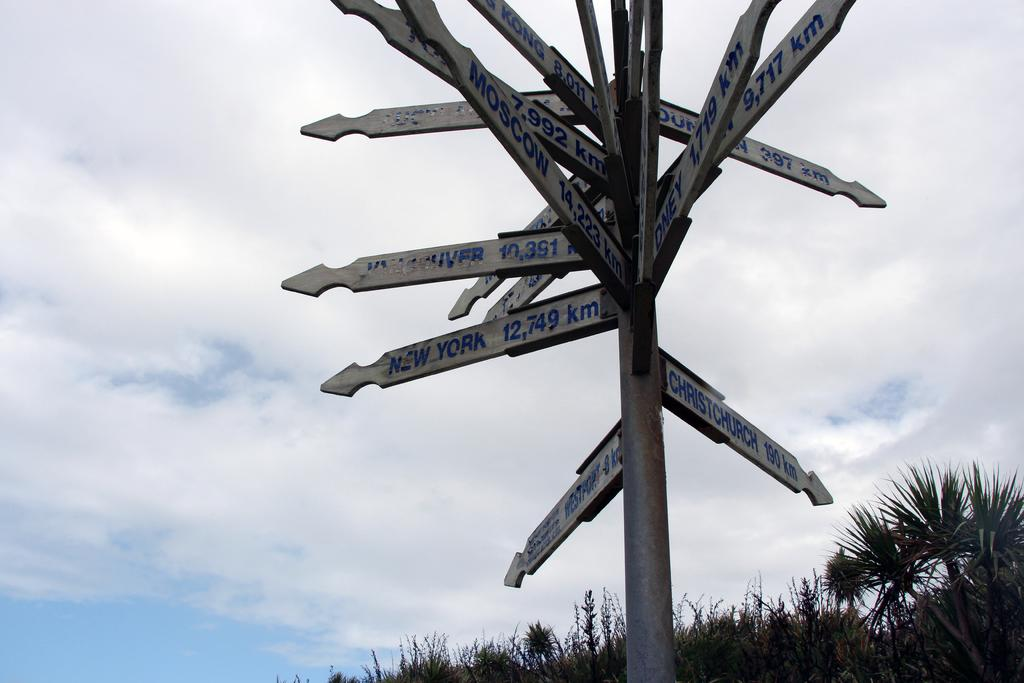<image>
Write a terse but informative summary of the picture. A sign that points to New York 12,749 km 